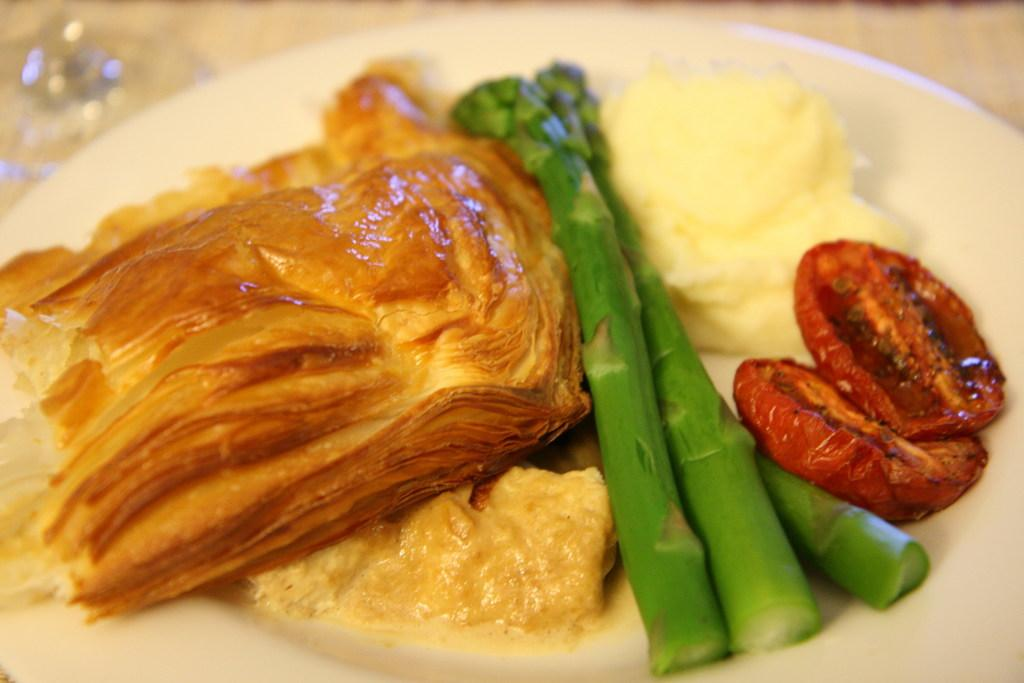What is on the plate in the image? The plate contains food. What colors can be seen in the food on the plate? The food has colors of brown, green, cream, and red. How would you describe the background of the image? The background of the image is blurred. What type of structure is visible in the background of the image? There is no structure visible in the background of the image; it is blurred. What level of detail can be seen in the food on the plate? The food on the plate has a variety of colors, including brown, green, cream, and red, but the level of detail cannot be determined from the image. 